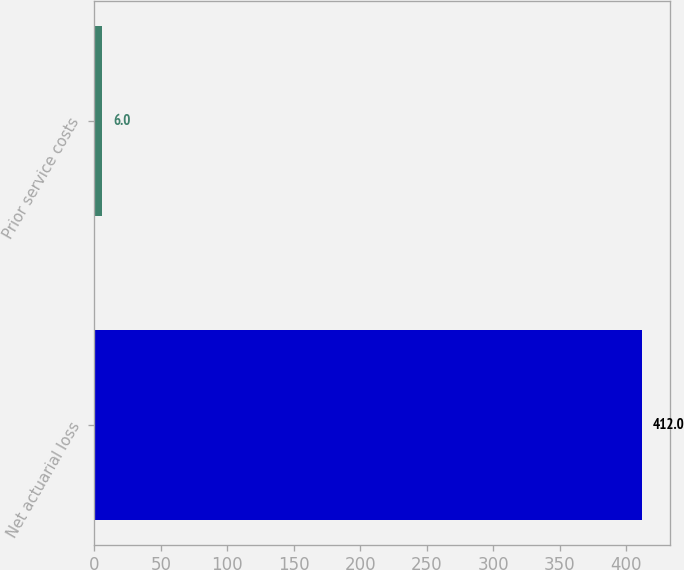<chart> <loc_0><loc_0><loc_500><loc_500><bar_chart><fcel>Net actuarial loss<fcel>Prior service costs<nl><fcel>412<fcel>6<nl></chart> 